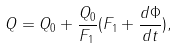Convert formula to latex. <formula><loc_0><loc_0><loc_500><loc_500>Q = Q _ { 0 } + \frac { Q _ { 0 } } { F _ { 1 } } ( F _ { 1 } + \frac { d \Phi } { d t } ) ,</formula> 